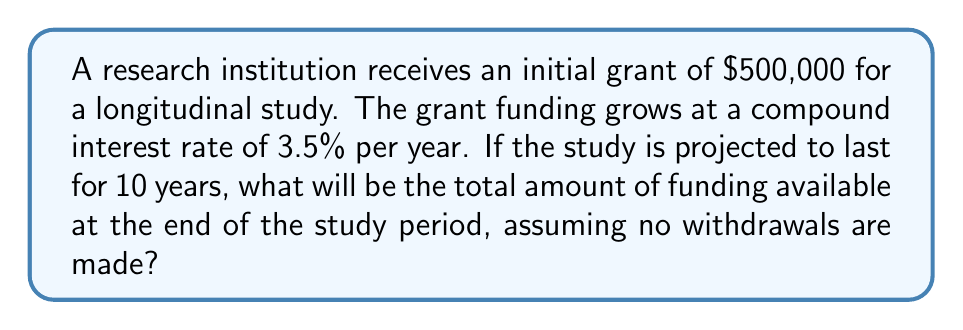Show me your answer to this math problem. To solve this problem, we'll use the compound interest formula:

$$A = P(1 + r)^n$$

Where:
$A$ = Final amount
$P$ = Principal (initial investment)
$r$ = Annual interest rate (in decimal form)
$n$ = Number of years

Given:
$P = \$500,000$
$r = 3.5\% = 0.035$
$n = 10$ years

Let's substitute these values into the formula:

$$A = 500,000(1 + 0.035)^{10}$$

Now, let's calculate step-by-step:

1. Calculate $(1 + 0.035)^{10}$:
   $$(1.035)^{10} \approx 1.4105$$

2. Multiply the result by the principal:
   $$500,000 \times 1.4105 = 705,250$$

Therefore, the total amount of funding available at the end of the 10-year study period will be $705,250.
Answer: $705,250 